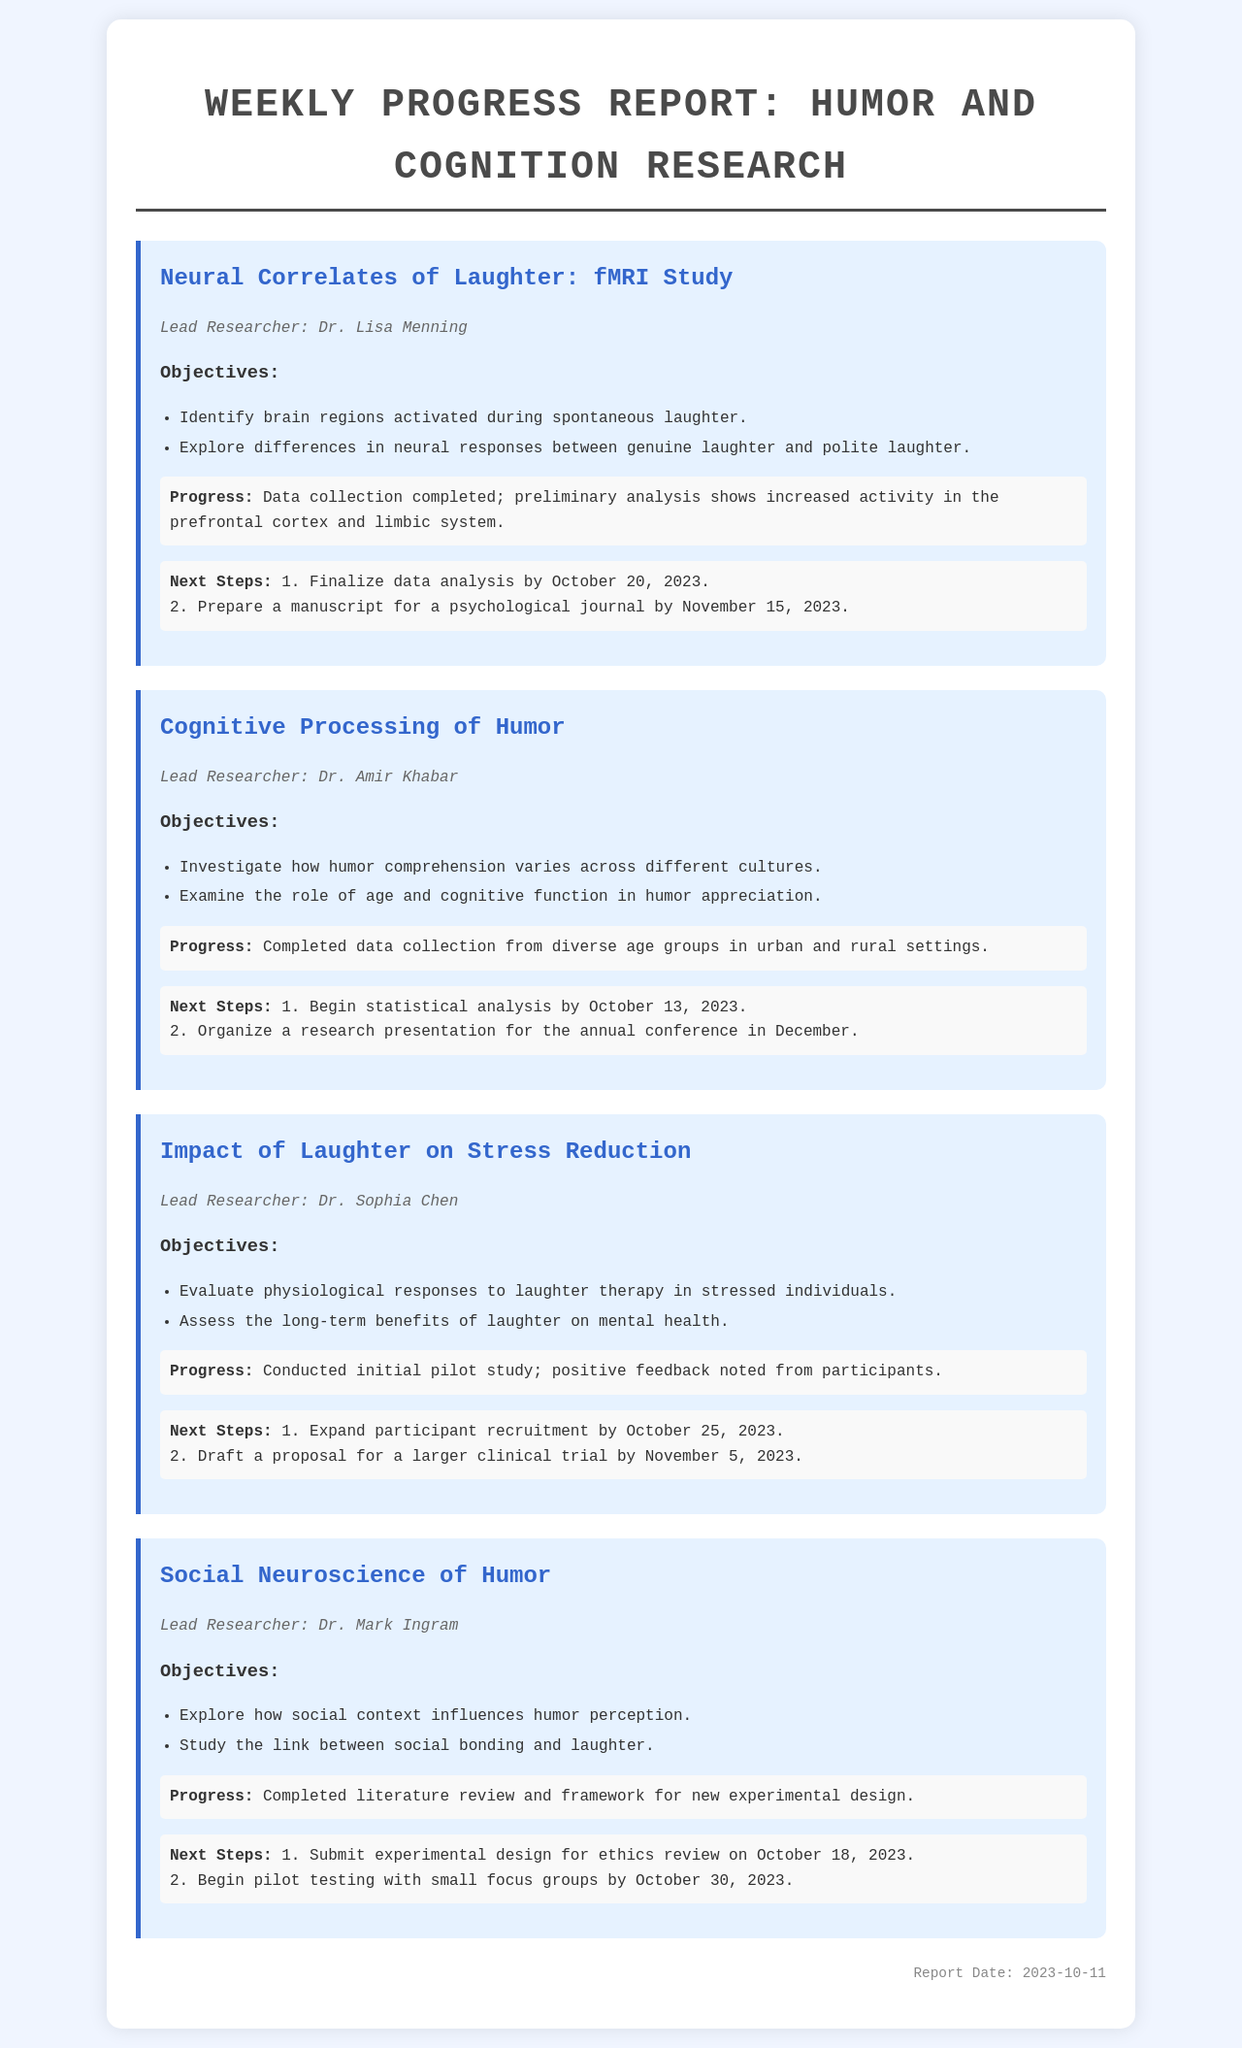What is the lead researcher's name for the fMRI study? The document lists Dr. Lisa Menning as the lead researcher for the fMRI study on neural correlates of laughter.
Answer: Dr. Lisa Menning Which brain regions are being studied in the laughter fMRI research? The objectives mention exploring brain regions activated during spontaneous laughter, specifically the prefrontal cortex and limbic system.
Answer: Prefrontal cortex and limbic system When is the statistical analysis scheduled to begin for the cognitive processing of humor project? The next steps stated that statistical analysis will begin by October 13, 2023.
Answer: October 13, 2023 What was the feedback from participants in the pilot study related to laughter therapy? Positive feedback was noted from participants, indicating a favorable response to the initial study conducted on laughter therapy.
Answer: Positive feedback What is the main objective of the social neuroscience of humor project? The main objective includes exploring how social context influences humor perception and studying the link between social bonding and laughter.
Answer: Explore how social context influences humor perception When is the ethics review submission deadline for the experimental design in the social neuroscience of humor project? The next steps indicate that the submission for ethics review is due on October 18, 2023.
Answer: October 18, 2023 What is one of the next steps for the laughter therapy project? One of the next steps in the laughter therapy project includes expanding participant recruitment.
Answer: Expand participant recruitment Which researcher is leading the study on cognitive processing of humor? The document states that Dr. Amir Khabar is the lead researcher for this project.
Answer: Dr. Amir Khabar Which date is the report published? The report date is noted at the bottom of the document as October 11, 2023.
Answer: October 11, 2023 